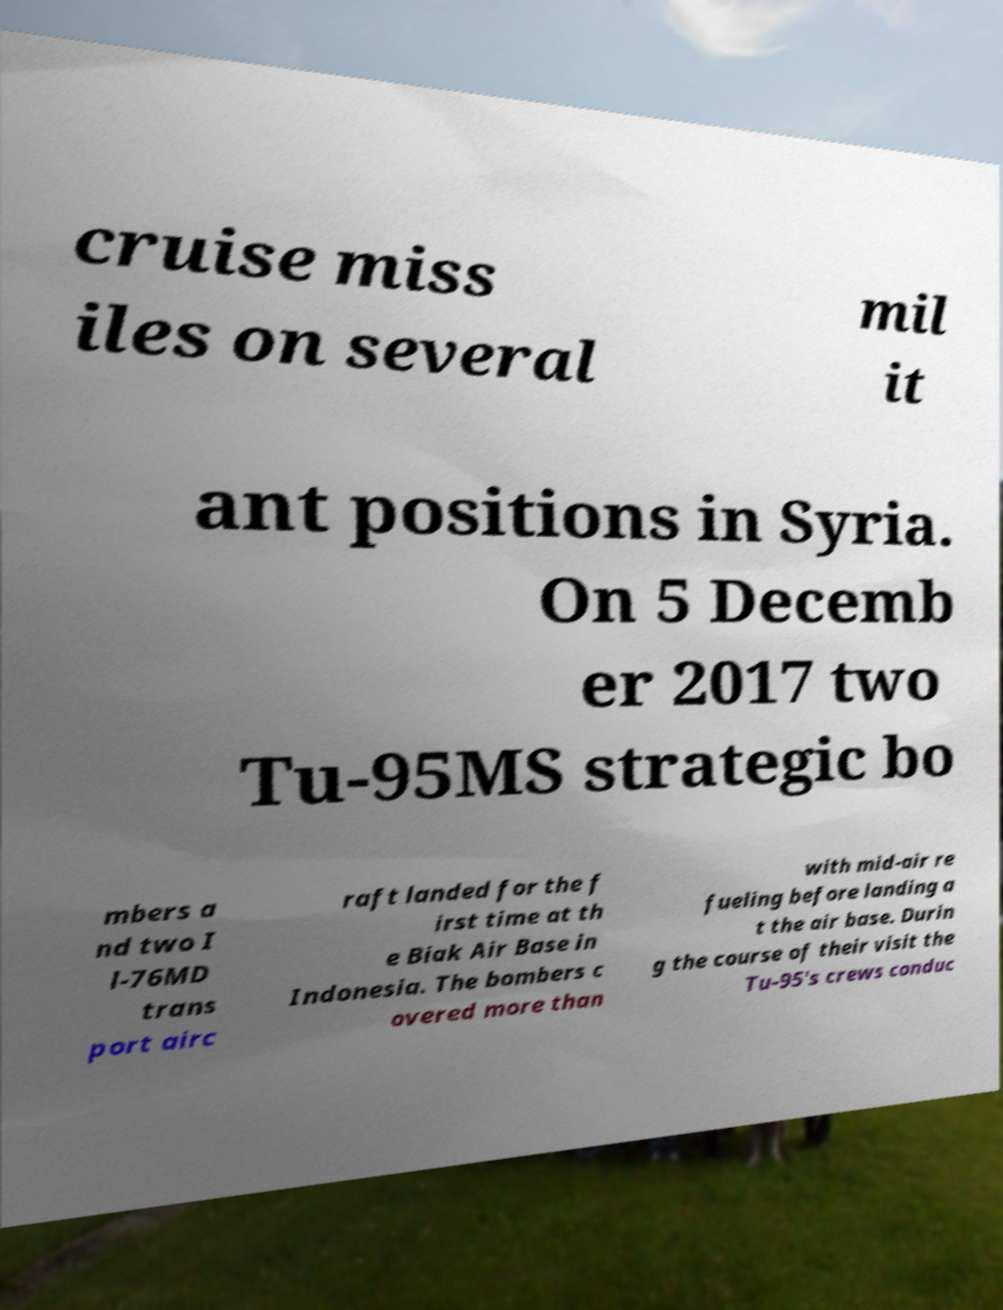Please read and relay the text visible in this image. What does it say? cruise miss iles on several mil it ant positions in Syria. On 5 Decemb er 2017 two Tu-95MS strategic bo mbers a nd two I l-76MD trans port airc raft landed for the f irst time at th e Biak Air Base in Indonesia. The bombers c overed more than with mid-air re fueling before landing a t the air base. Durin g the course of their visit the Tu-95's crews conduc 